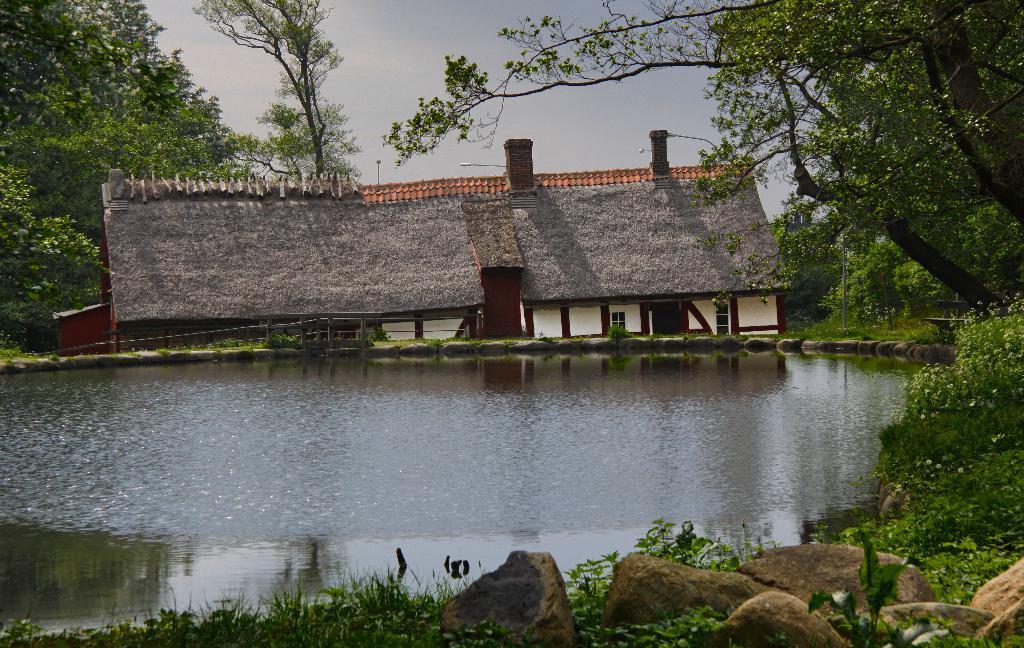In one or two sentences, can you explain what this image depicts? As we can see in the image there is water, houses, rocks, plants and trees. At the top there is sky. 